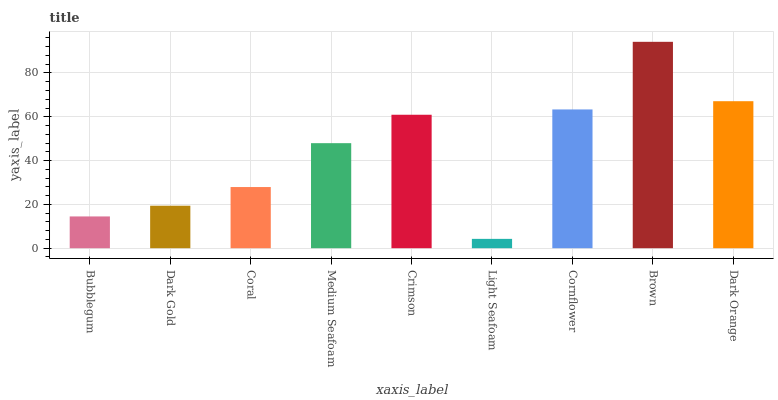Is Light Seafoam the minimum?
Answer yes or no. Yes. Is Brown the maximum?
Answer yes or no. Yes. Is Dark Gold the minimum?
Answer yes or no. No. Is Dark Gold the maximum?
Answer yes or no. No. Is Dark Gold greater than Bubblegum?
Answer yes or no. Yes. Is Bubblegum less than Dark Gold?
Answer yes or no. Yes. Is Bubblegum greater than Dark Gold?
Answer yes or no. No. Is Dark Gold less than Bubblegum?
Answer yes or no. No. Is Medium Seafoam the high median?
Answer yes or no. Yes. Is Medium Seafoam the low median?
Answer yes or no. Yes. Is Dark Orange the high median?
Answer yes or no. No. Is Cornflower the low median?
Answer yes or no. No. 